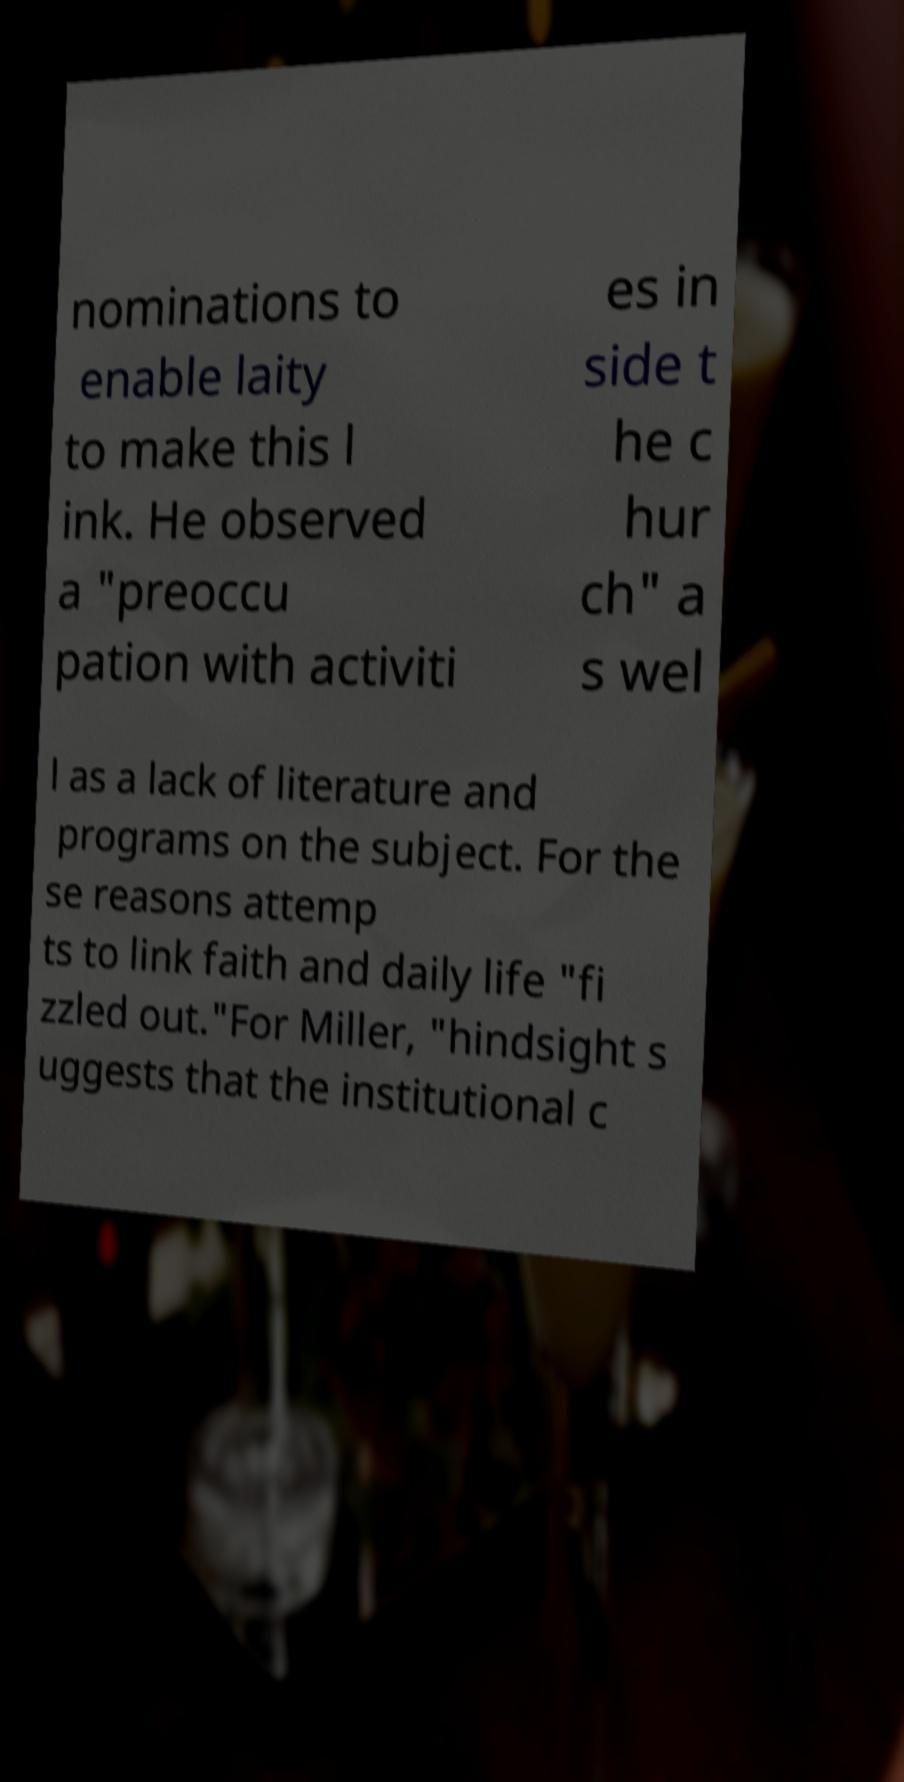Could you assist in decoding the text presented in this image and type it out clearly? nominations to enable laity to make this l ink. He observed a "preoccu pation with activiti es in side t he c hur ch" a s wel l as a lack of literature and programs on the subject. For the se reasons attemp ts to link faith and daily life "fi zzled out."For Miller, "hindsight s uggests that the institutional c 